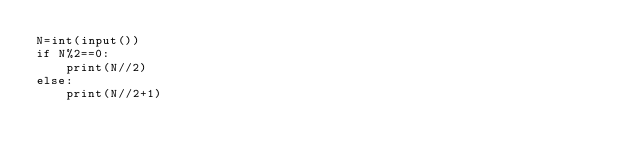<code> <loc_0><loc_0><loc_500><loc_500><_Python_>N=int(input())
if N%2==0:
    print(N//2)
else:
    print(N//2+1)</code> 